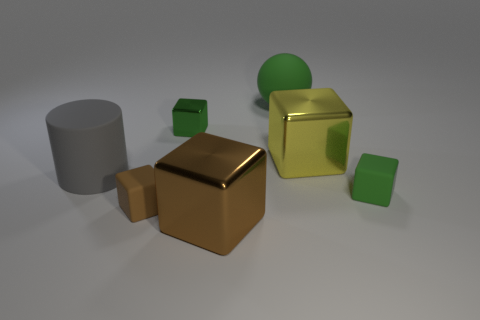How many things are either cyan matte cubes or tiny blocks that are to the right of the brown shiny object?
Ensure brevity in your answer.  1. Is the number of brown shiny blocks that are right of the green metal block less than the number of objects that are in front of the yellow shiny cube?
Make the answer very short. Yes. What number of other objects are there of the same material as the cylinder?
Offer a terse response. 3. Does the tiny block behind the green matte block have the same color as the rubber sphere?
Your answer should be compact. Yes. Is there a matte cube on the right side of the large object in front of the tiny green rubber cube?
Make the answer very short. Yes. There is a thing that is both behind the large yellow metal block and on the left side of the big green sphere; what material is it?
Your answer should be compact. Metal. The gray thing that is made of the same material as the small brown object is what shape?
Offer a terse response. Cylinder. Is there anything else that is the same shape as the gray thing?
Your answer should be compact. No. Are the block that is behind the yellow shiny thing and the large yellow cube made of the same material?
Give a very brief answer. Yes. What is the material of the large block that is in front of the tiny brown rubber thing?
Give a very brief answer. Metal. 